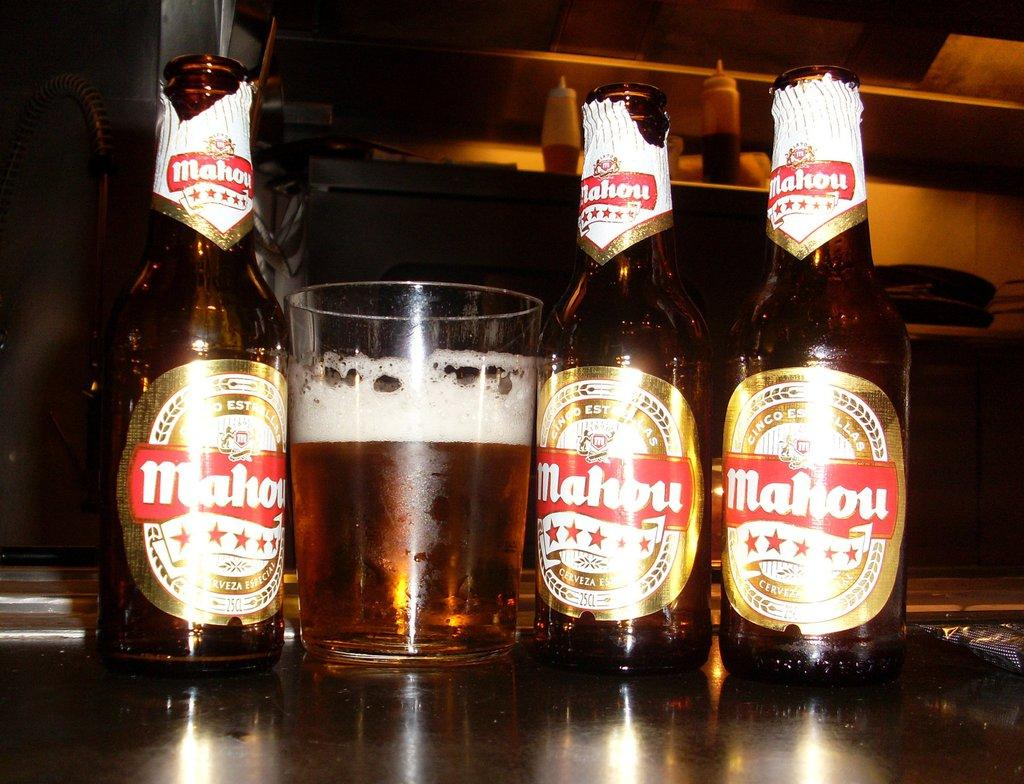<image>
Relay a brief, clear account of the picture shown. three bottles of cinco estrellas mahou that say 'cerveza' on them 